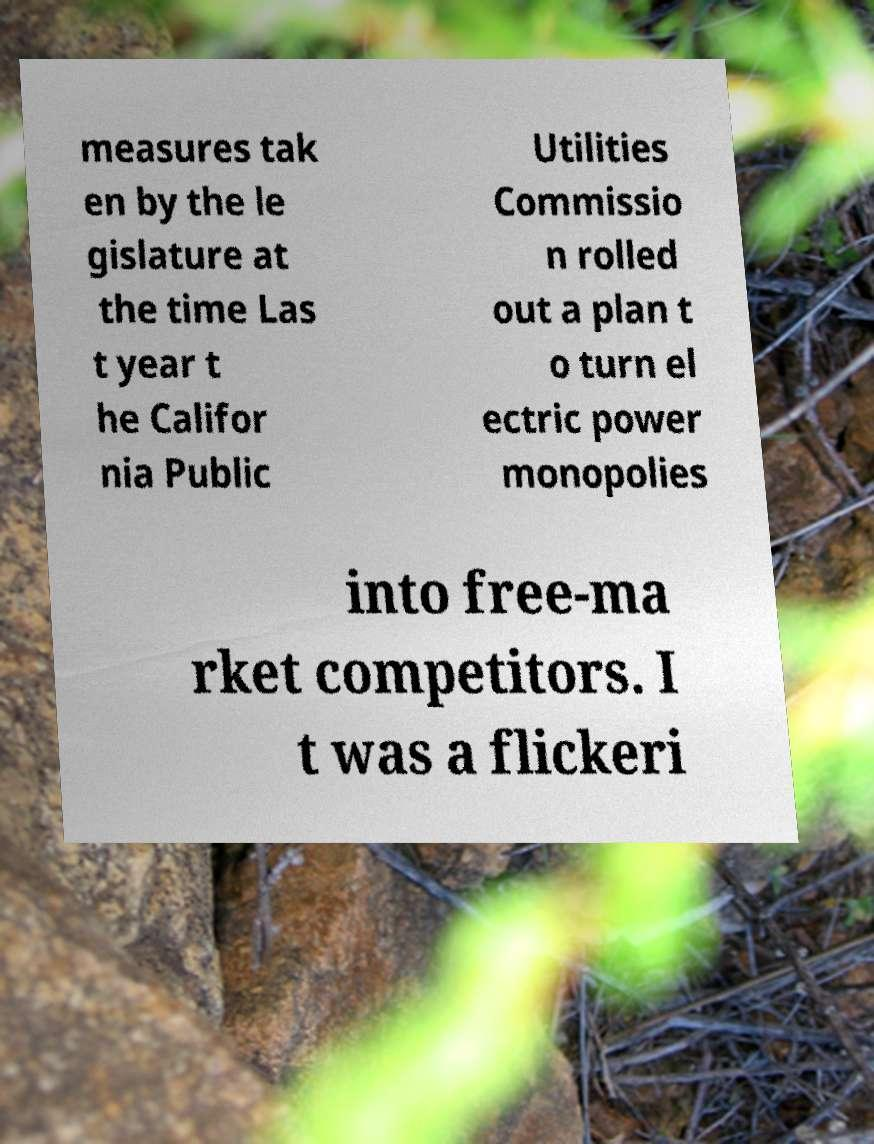Could you extract and type out the text from this image? measures tak en by the le gislature at the time Las t year t he Califor nia Public Utilities Commissio n rolled out a plan t o turn el ectric power monopolies into free-ma rket competitors. I t was a flickeri 